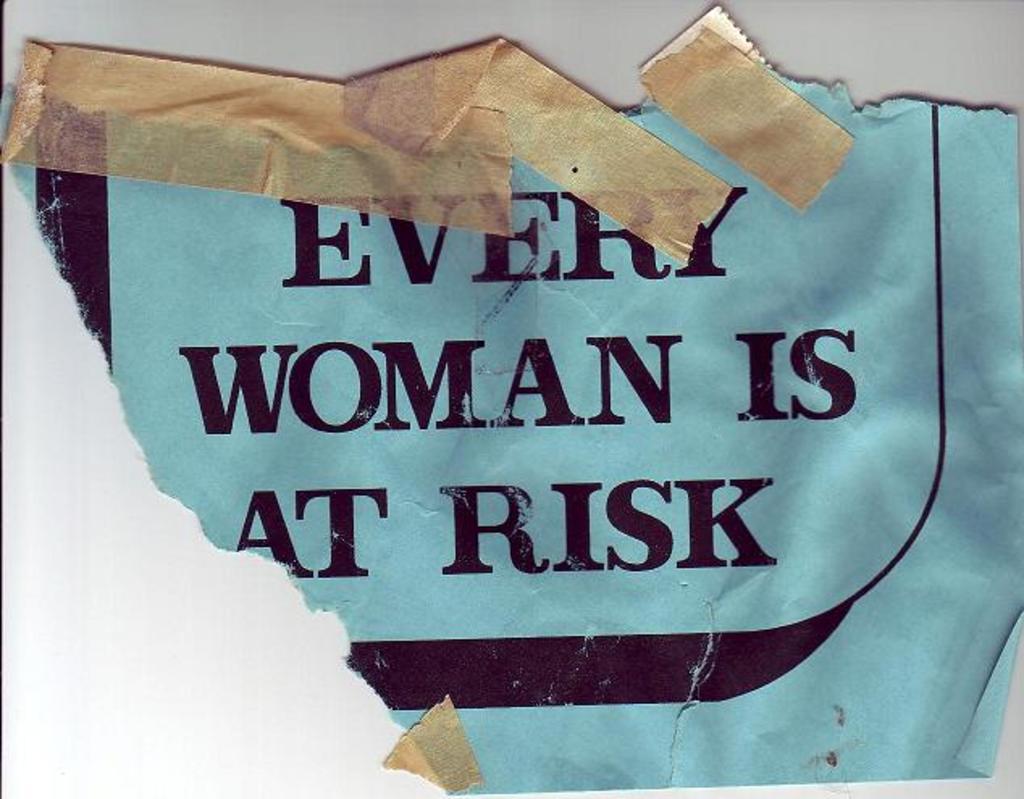Who is at risk?
Your answer should be compact. Every woman. 